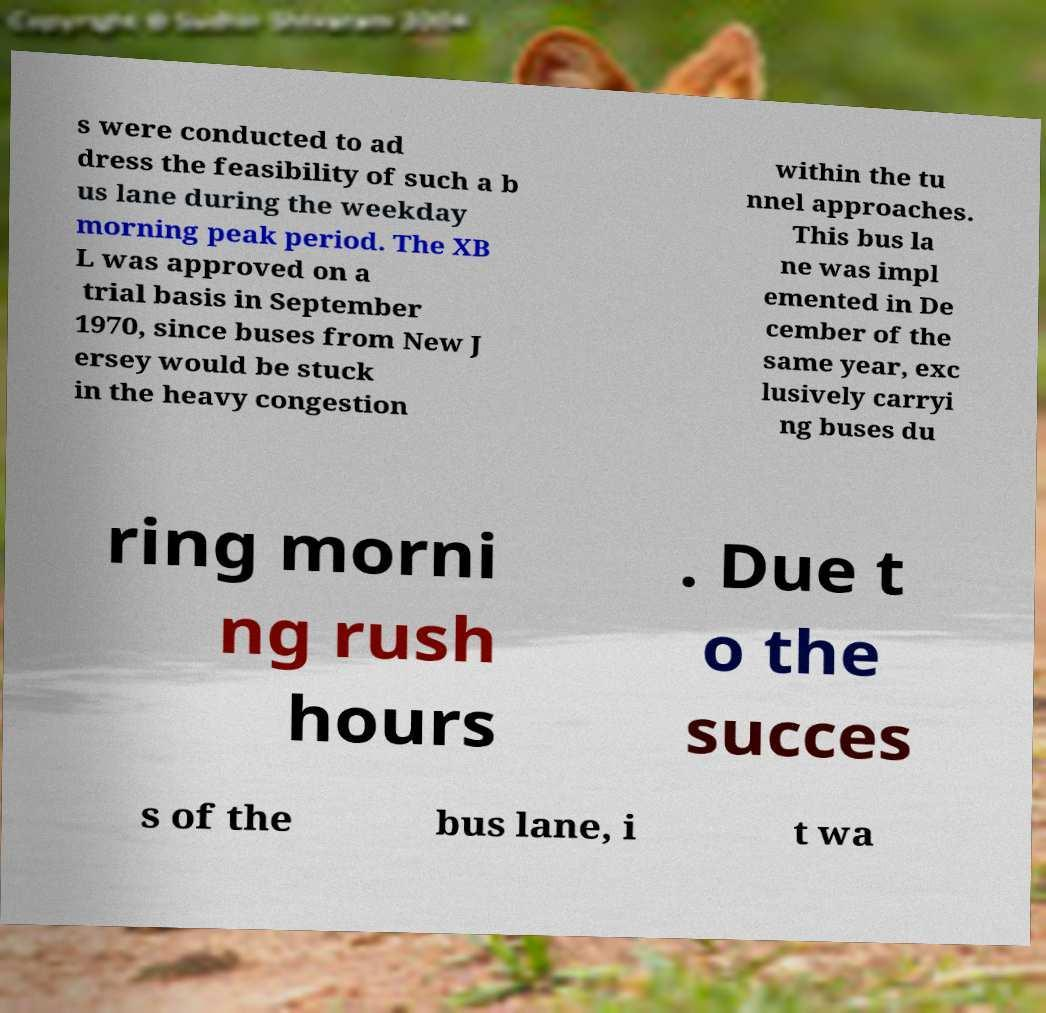I need the written content from this picture converted into text. Can you do that? s were conducted to ad dress the feasibility of such a b us lane during the weekday morning peak period. The XB L was approved on a trial basis in September 1970, since buses from New J ersey would be stuck in the heavy congestion within the tu nnel approaches. This bus la ne was impl emented in De cember of the same year, exc lusively carryi ng buses du ring morni ng rush hours . Due t o the succes s of the bus lane, i t wa 